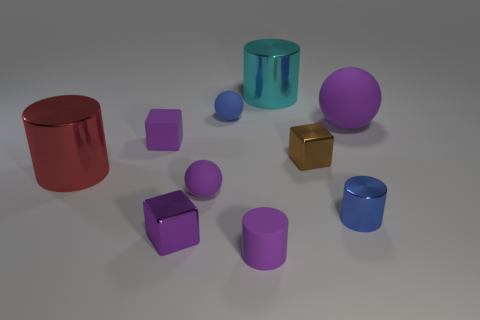Are there any small shiny blocks behind the purple metallic object?
Keep it short and to the point. Yes. Do the big matte sphere and the rubber cylinder have the same color?
Keep it short and to the point. Yes. What number of big rubber things have the same color as the large sphere?
Provide a short and direct response. 0. There is a rubber ball that is on the right side of the tiny purple rubber object in front of the small shiny cylinder; how big is it?
Keep it short and to the point. Large. What is the shape of the blue rubber object?
Give a very brief answer. Sphere. What is the material of the blue thing in front of the big red thing?
Provide a short and direct response. Metal. There is a matte block on the left side of the small blue object that is in front of the rubber sphere that is to the left of the tiny blue matte object; what is its color?
Offer a terse response. Purple. There is a sphere that is the same size as the red metal object; what color is it?
Give a very brief answer. Purple. How many shiny objects are either blue cylinders or cyan cylinders?
Your answer should be very brief. 2. What color is the other block that is the same material as the brown block?
Ensure brevity in your answer.  Purple. 